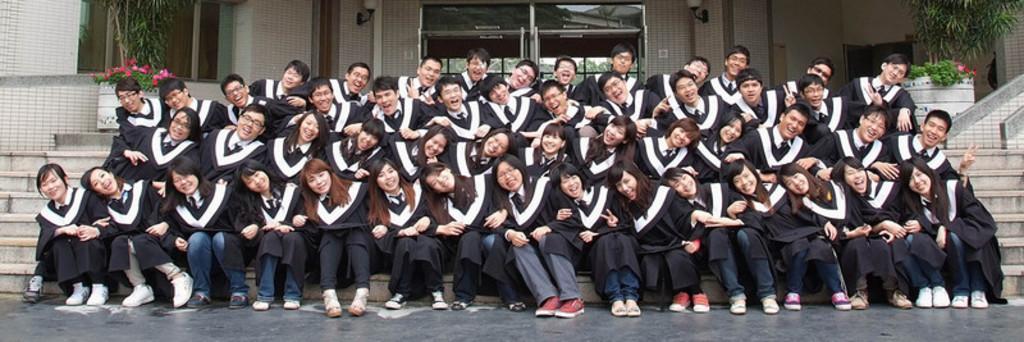How would you summarize this image in a sentence or two? In this image, we can see a group of people wearing clothes and sitting on the steps in front of the building. There is a plant in the top left and in the top right of the image. There is a door at the top of the image. 